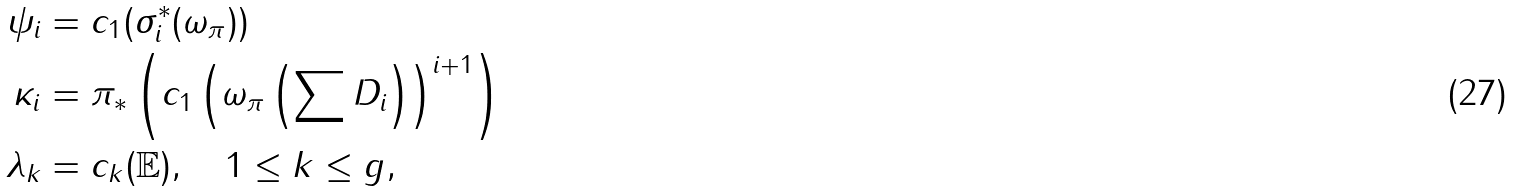Convert formula to latex. <formula><loc_0><loc_0><loc_500><loc_500>\psi _ { i } & = c _ { 1 } ( \sigma _ { i } ^ { * } ( \omega _ { \pi } ) ) \\ \kappa _ { i } & = \pi _ { * } \left ( c _ { 1 } \left ( \omega _ { \pi } \left ( \sum D _ { i } \right ) \right ) ^ { i + 1 } \right ) \\ \lambda _ { k } & = c _ { k } ( \mathbb { E } ) , \quad 1 \leq k \leq g ,</formula> 